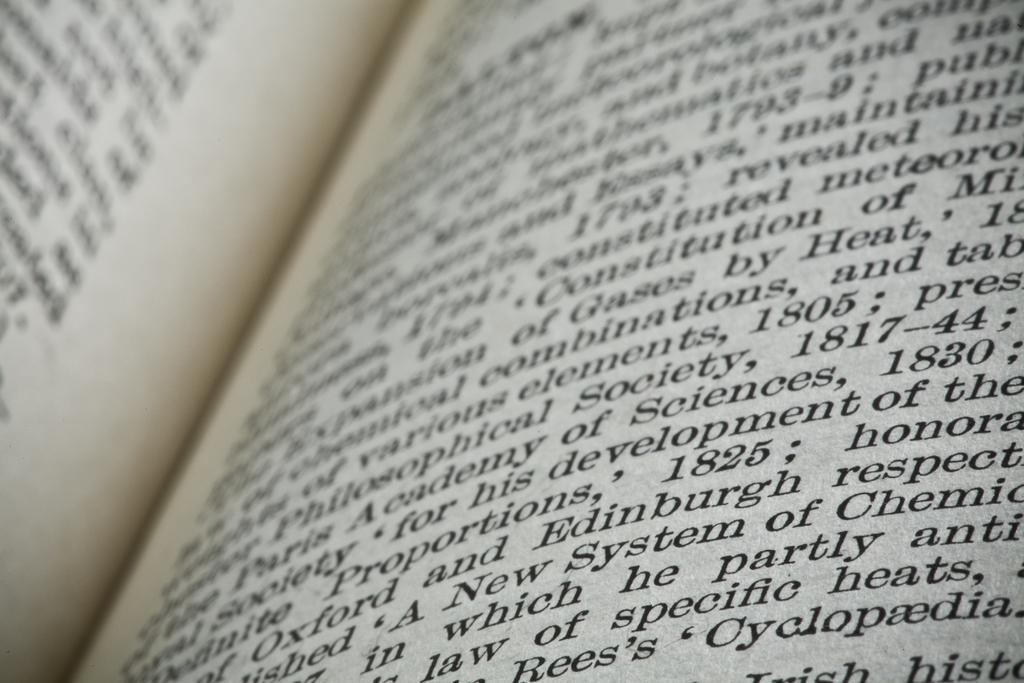<image>
Write a terse but informative summary of the picture. A book is open and one of the words reads system. 